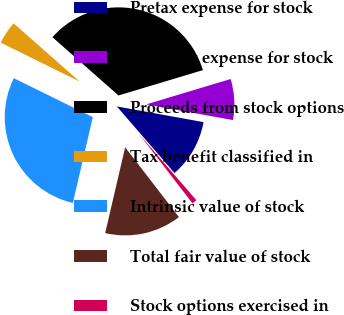Convert chart. <chart><loc_0><loc_0><loc_500><loc_500><pie_chart><fcel>Pretax expense for stock<fcel>After-tax expense for stock<fcel>Proceeds from stock options<fcel>Tax benefit classified in<fcel>Intrinsic value of stock<fcel>Total fair value of stock<fcel>Stock options exercised in<nl><fcel>10.79%<fcel>7.5%<fcel>33.85%<fcel>4.21%<fcel>28.65%<fcel>14.09%<fcel>0.91%<nl></chart> 